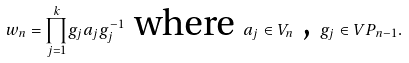Convert formula to latex. <formula><loc_0><loc_0><loc_500><loc_500>w _ { n } = \underset { j = 1 } { \overset { k } { \prod } } g _ { j } a _ { j } g _ { j } ^ { - 1 } \text { where } a _ { j } \in V _ { n } \text { , } g _ { j } \in V P _ { n - 1 } .</formula> 